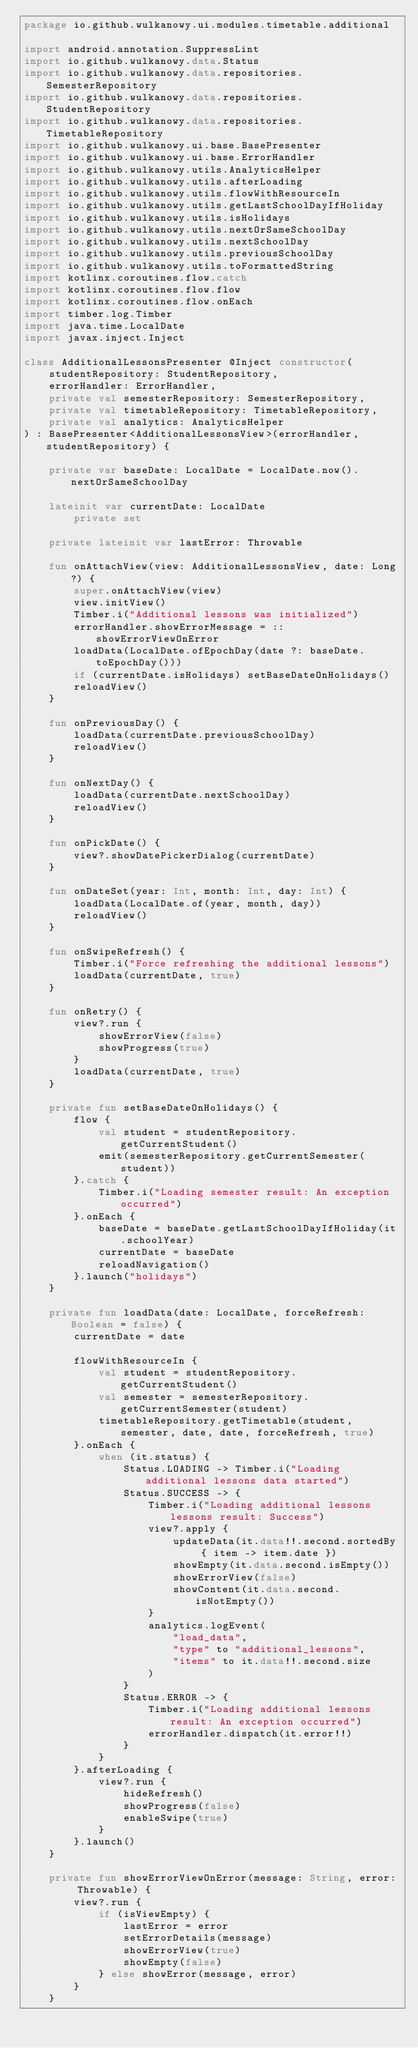<code> <loc_0><loc_0><loc_500><loc_500><_Kotlin_>package io.github.wulkanowy.ui.modules.timetable.additional

import android.annotation.SuppressLint
import io.github.wulkanowy.data.Status
import io.github.wulkanowy.data.repositories.SemesterRepository
import io.github.wulkanowy.data.repositories.StudentRepository
import io.github.wulkanowy.data.repositories.TimetableRepository
import io.github.wulkanowy.ui.base.BasePresenter
import io.github.wulkanowy.ui.base.ErrorHandler
import io.github.wulkanowy.utils.AnalyticsHelper
import io.github.wulkanowy.utils.afterLoading
import io.github.wulkanowy.utils.flowWithResourceIn
import io.github.wulkanowy.utils.getLastSchoolDayIfHoliday
import io.github.wulkanowy.utils.isHolidays
import io.github.wulkanowy.utils.nextOrSameSchoolDay
import io.github.wulkanowy.utils.nextSchoolDay
import io.github.wulkanowy.utils.previousSchoolDay
import io.github.wulkanowy.utils.toFormattedString
import kotlinx.coroutines.flow.catch
import kotlinx.coroutines.flow.flow
import kotlinx.coroutines.flow.onEach
import timber.log.Timber
import java.time.LocalDate
import javax.inject.Inject

class AdditionalLessonsPresenter @Inject constructor(
    studentRepository: StudentRepository,
    errorHandler: ErrorHandler,
    private val semesterRepository: SemesterRepository,
    private val timetableRepository: TimetableRepository,
    private val analytics: AnalyticsHelper
) : BasePresenter<AdditionalLessonsView>(errorHandler, studentRepository) {

    private var baseDate: LocalDate = LocalDate.now().nextOrSameSchoolDay

    lateinit var currentDate: LocalDate
        private set

    private lateinit var lastError: Throwable

    fun onAttachView(view: AdditionalLessonsView, date: Long?) {
        super.onAttachView(view)
        view.initView()
        Timber.i("Additional lessons was initialized")
        errorHandler.showErrorMessage = ::showErrorViewOnError
        loadData(LocalDate.ofEpochDay(date ?: baseDate.toEpochDay()))
        if (currentDate.isHolidays) setBaseDateOnHolidays()
        reloadView()
    }

    fun onPreviousDay() {
        loadData(currentDate.previousSchoolDay)
        reloadView()
    }

    fun onNextDay() {
        loadData(currentDate.nextSchoolDay)
        reloadView()
    }

    fun onPickDate() {
        view?.showDatePickerDialog(currentDate)
    }

    fun onDateSet(year: Int, month: Int, day: Int) {
        loadData(LocalDate.of(year, month, day))
        reloadView()
    }

    fun onSwipeRefresh() {
        Timber.i("Force refreshing the additional lessons")
        loadData(currentDate, true)
    }

    fun onRetry() {
        view?.run {
            showErrorView(false)
            showProgress(true)
        }
        loadData(currentDate, true)
    }

    private fun setBaseDateOnHolidays() {
        flow {
            val student = studentRepository.getCurrentStudent()
            emit(semesterRepository.getCurrentSemester(student))
        }.catch {
            Timber.i("Loading semester result: An exception occurred")
        }.onEach {
            baseDate = baseDate.getLastSchoolDayIfHoliday(it.schoolYear)
            currentDate = baseDate
            reloadNavigation()
        }.launch("holidays")
    }

    private fun loadData(date: LocalDate, forceRefresh: Boolean = false) {
        currentDate = date

        flowWithResourceIn {
            val student = studentRepository.getCurrentStudent()
            val semester = semesterRepository.getCurrentSemester(student)
            timetableRepository.getTimetable(student, semester, date, date, forceRefresh, true)
        }.onEach {
            when (it.status) {
                Status.LOADING -> Timber.i("Loading additional lessons data started")
                Status.SUCCESS -> {
                    Timber.i("Loading additional lessons lessons result: Success")
                    view?.apply {
                        updateData(it.data!!.second.sortedBy { item -> item.date })
                        showEmpty(it.data.second.isEmpty())
                        showErrorView(false)
                        showContent(it.data.second.isNotEmpty())
                    }
                    analytics.logEvent(
                        "load_data",
                        "type" to "additional_lessons",
                        "items" to it.data!!.second.size
                    )
                }
                Status.ERROR -> {
                    Timber.i("Loading additional lessons result: An exception occurred")
                    errorHandler.dispatch(it.error!!)
                }
            }
        }.afterLoading {
            view?.run {
                hideRefresh()
                showProgress(false)
                enableSwipe(true)
            }
        }.launch()
    }

    private fun showErrorViewOnError(message: String, error: Throwable) {
        view?.run {
            if (isViewEmpty) {
                lastError = error
                setErrorDetails(message)
                showErrorView(true)
                showEmpty(false)
            } else showError(message, error)
        }
    }
</code> 